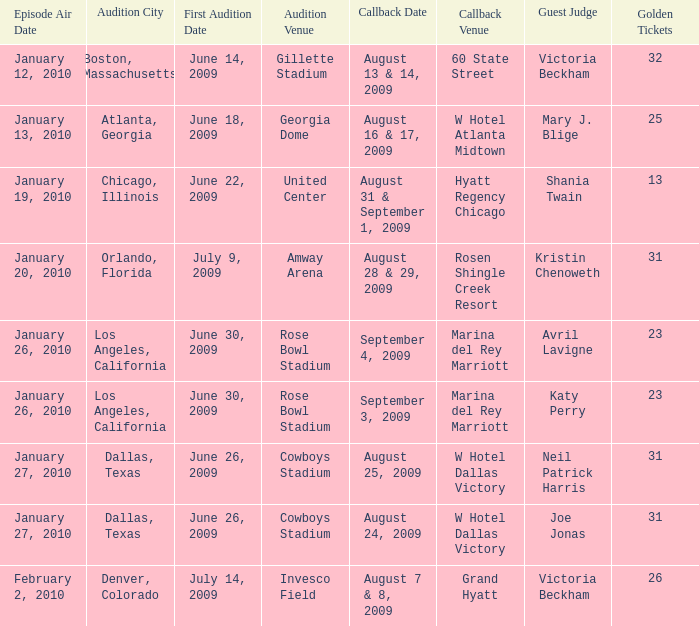Name the callback date for amway arena August 28 & 29, 2009. 